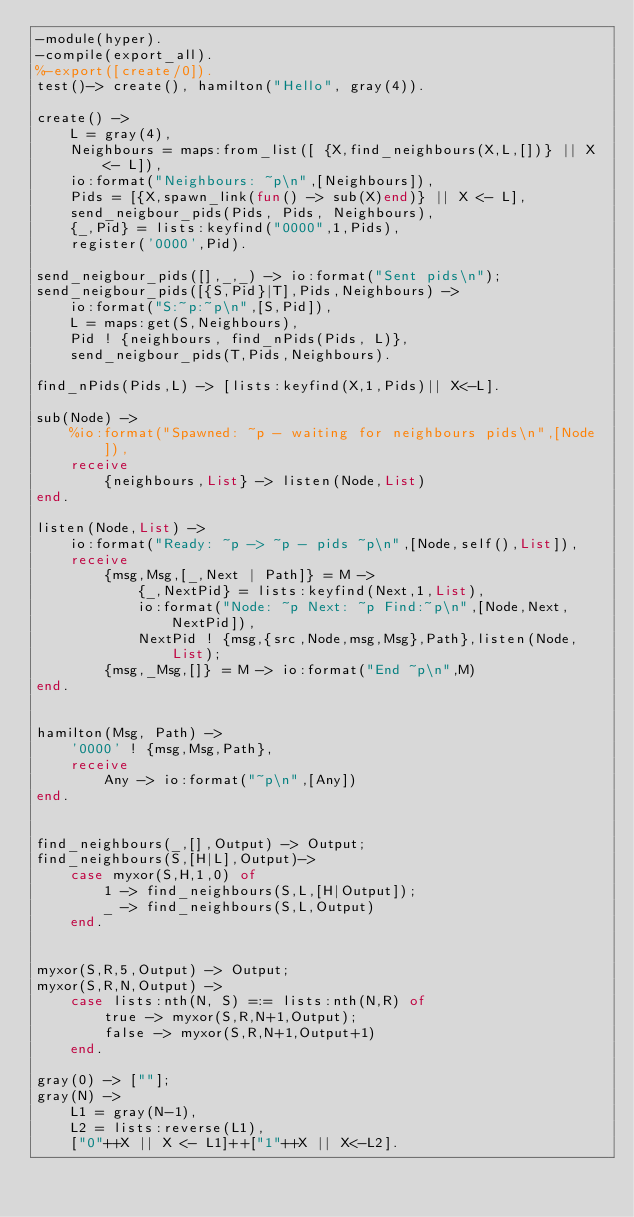Convert code to text. <code><loc_0><loc_0><loc_500><loc_500><_Erlang_>-module(hyper).
-compile(export_all).
%-export([create/0]).
test()-> create(), hamilton("Hello", gray(4)).

create() ->
    L = gray(4),
    Neighbours = maps:from_list([ {X,find_neighbours(X,L,[])} || X <- L]),    
    io:format("Neighbours: ~p\n",[Neighbours]),
    Pids = [{X,spawn_link(fun() -> sub(X)end)} || X <- L],
    send_neigbour_pids(Pids, Pids, Neighbours),
    {_,Pid} = lists:keyfind("0000",1,Pids),
    register('0000',Pid).

send_neigbour_pids([],_,_) -> io:format("Sent pids\n");
send_neigbour_pids([{S,Pid}|T],Pids,Neighbours) ->
    io:format("S:~p:~p\n",[S,Pid]),
    L = maps:get(S,Neighbours),
    Pid ! {neighbours, find_nPids(Pids, L)},
    send_neigbour_pids(T,Pids,Neighbours).

find_nPids(Pids,L) -> [lists:keyfind(X,1,Pids)|| X<-L].

sub(Node) ->
    %io:format("Spawned: ~p - waiting for neighbours pids\n",[Node]),
    receive
        {neighbours,List} -> listen(Node,List)
end.

listen(Node,List) ->
    io:format("Ready: ~p -> ~p - pids ~p\n",[Node,self(),List]),
    receive
        {msg,Msg,[_,Next | Path]} = M ->  
            {_,NextPid} = lists:keyfind(Next,1,List),
            io:format("Node: ~p Next: ~p Find:~p\n",[Node,Next,NextPid]),
            NextPid ! {msg,{src,Node,msg,Msg},Path},listen(Node,List);
        {msg,_Msg,[]} = M -> io:format("End ~p\n",M)
end.

    
hamilton(Msg, Path) ->
    '0000' ! {msg,Msg,Path},
    receive 
        Any -> io:format("~p\n",[Any])
end.


find_neighbours(_,[],Output) -> Output;
find_neighbours(S,[H|L],Output)->    
    case myxor(S,H,1,0) of
        1 -> find_neighbours(S,L,[H|Output]);
        _ -> find_neighbours(S,L,Output)
    end.


myxor(S,R,5,Output) -> Output;
myxor(S,R,N,Output) ->
    case lists:nth(N, S) =:= lists:nth(N,R) of
        true -> myxor(S,R,N+1,Output);
        false -> myxor(S,R,N+1,Output+1)
    end.

gray(0) -> [""];
gray(N) ->
    L1 = gray(N-1),
    L2 = lists:reverse(L1),
    ["0"++X || X <- L1]++["1"++X || X<-L2].</code> 